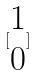Convert formula to latex. <formula><loc_0><loc_0><loc_500><loc_500>[ \begin{matrix} 1 \\ 0 \end{matrix} ]</formula> 